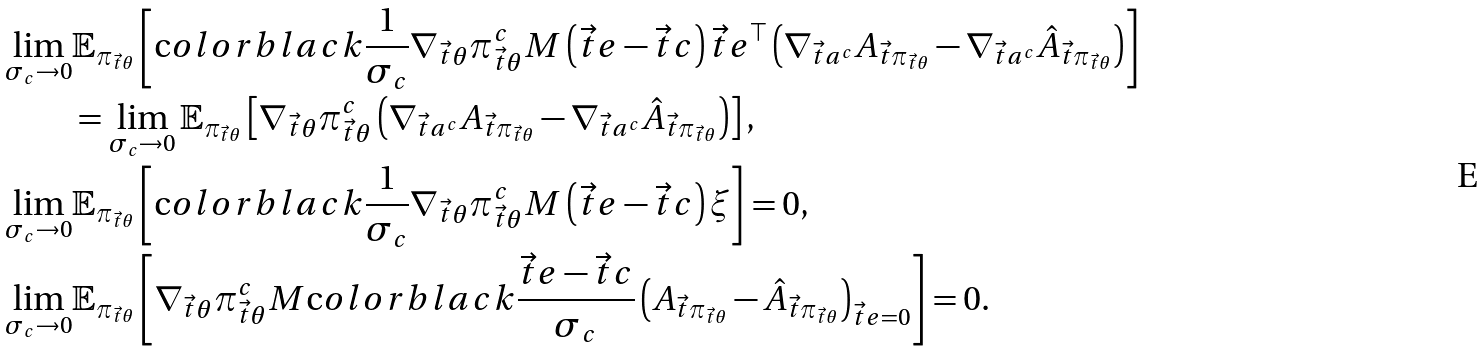<formula> <loc_0><loc_0><loc_500><loc_500>\lim _ { \sigma _ { c } \rightarrow 0 } & \mathbb { E } _ { \pi _ { \vec { t } \theta } } \left [ \text  color{black} { \frac { 1 } { \sigma _ { c } } } \nabla _ { \vec { t } \theta } \pi ^ { c } _ { \vec { t } \theta } M \left ( \vec { t } e - \vec { t } c \right ) \vec { t } e ^ { \top } \left ( \nabla _ { \vec { t } a ^ { c } } A _ { \vec { t } \pi _ { \vec { t } \theta } } - \nabla _ { \vec { t } a ^ { c } } \hat { A } _ { \vec { t } \pi _ { \vec { t } \theta } } \right ) \right ] \\ & = \lim _ { \sigma _ { c } \rightarrow 0 } \mathbb { E } _ { \pi _ { \vec { t } \theta } } \left [ \nabla _ { \vec { t } \theta } \pi ^ { c } _ { \vec { t } \theta } \left ( \nabla _ { \vec { t } a ^ { c } } A _ { \vec { t } \pi _ { \vec { t } \theta } } - \nabla _ { \vec { t } a ^ { c } } \hat { A } _ { \vec { t } \pi _ { \vec { t } \theta } } \right ) \right ] , \\ \lim _ { \sigma _ { c } \rightarrow 0 } & \mathbb { E } _ { \pi _ { \vec { t } \theta } } \left [ \text  color{black} { \frac { 1 } { \sigma _ { c } } } \nabla _ { \vec { t } \theta } \pi ^ { c } _ { \vec { t } \theta } M \left ( \vec { t } e - \vec { t } c \right ) \xi \right ] = 0 , \\ \lim _ { \sigma _ { c } \rightarrow 0 } & \mathbb { E } _ { \pi _ { \vec { t } \theta } } \left [ \nabla _ { \vec { t } \theta } \pi ^ { c } _ { \vec { t } \theta } M \text  color{black} { \frac { \vec { t } e - \vec { t } c } { \sigma _ { c } } } \left ( A _ { \vec { t } \pi _ { \vec { t } \theta } } - \hat { A } _ { \vec { t } \pi _ { \vec { t } \theta } } \right ) _ { \vec { t } e = 0 } \right ] = 0 .</formula> 